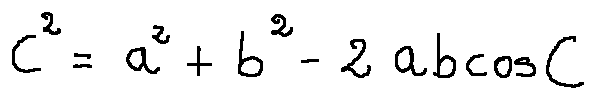Convert formula to latex. <formula><loc_0><loc_0><loc_500><loc_500>c ^ { 2 } = a ^ { 2 } + b ^ { 2 } - 2 a b \cos C</formula> 